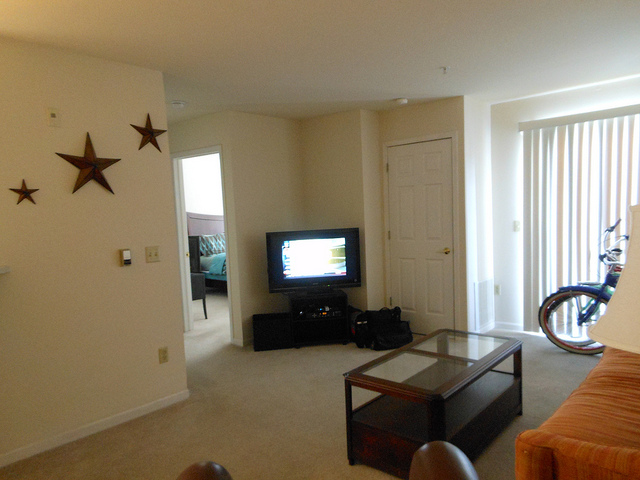<image>What holiday is depicted in this photo? It is not clear what holiday is depicted in the photo. It could be Easter, Catholic or Christmas. Why is the coffee table empty? It is unknown why the coffee table is empty. It could be because it's not being used or no one is home. What holiday is depicted in this photo? It is ambiguous which holiday is depicted in the photo. It can be Easter or Christmas. Why is the coffee table empty? I don't know why the coffee table is empty. It can be because it's clean, not being used, or no one is using it. 